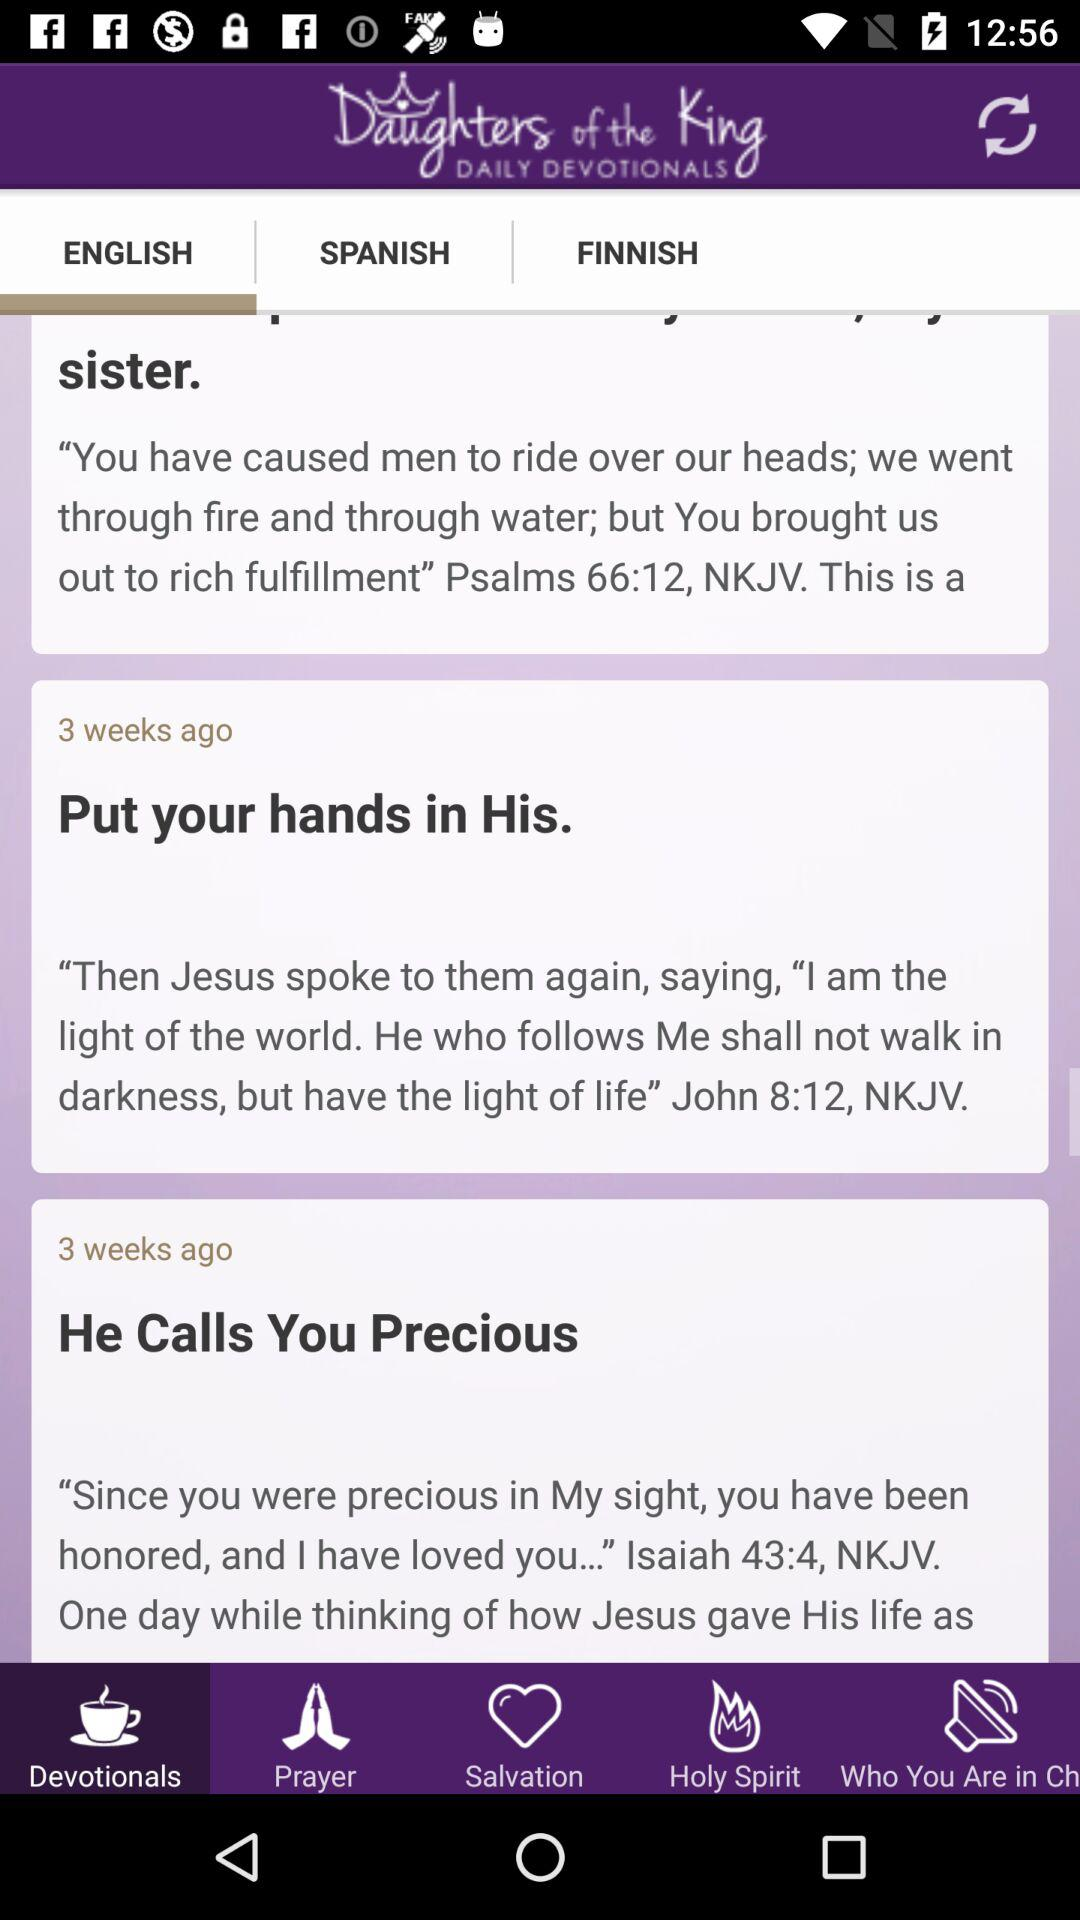How many devotionals are there in total?
Answer the question using a single word or phrase. 3 